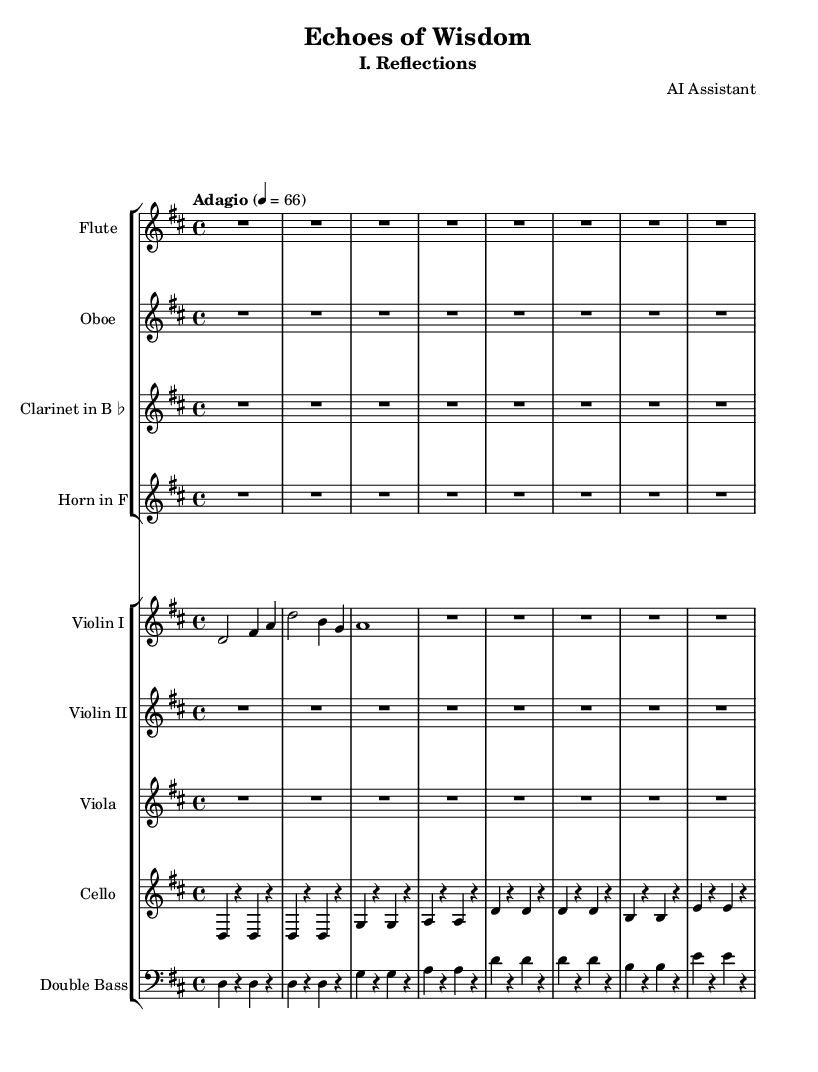What is the key signature of this music? The key signature is D major, which has two sharps (F# and C#). This can be identified by looking at the key signature area at the beginning of the staff.
Answer: D major What is the time signature of this music? The time signature is 4/4, as indicated at the beginning of the score next to the key signature. This means there are four beats in each measure, and the quarter note receives one beat.
Answer: 4/4 What is the tempo marking of this movement? The tempo marking is Adagio, which indicates that the music is to be played slowly. This marking is found at the beginning of the score along with the metronome marking of 66 beats per minute.
Answer: Adagio How long is the first violin's first note? The first violin's first note is a half note (d) which is held for two beats. This information is read directly from the note symbol in the staff.
Answer: half note How many instruments are indicated in the orchestration? The orchestration includes eight instruments, as counted from the four instruments in each of the two staff groups. The first group has flute, oboe, clarinet, and horn, while the second group consists of violin I, violin II, viola, cello, and double bass.
Answer: eight instruments What is the rhythmic value of the cello's first note? The cello's first note is a quarter note (d) as it is represented by the filled note head with a stem, which typically lasts for one beat in a 4/4 time signature.
Answer: quarter note What type of movement is characterized by its contemplative nature in this symphony? The movement is characterized as slow and contemplative, typically associating with the emotional depth and reflections that come with wisdom, as emphasized by the tempo marking of Adagio and the choice of instrumentation.
Answer: slow and contemplative 